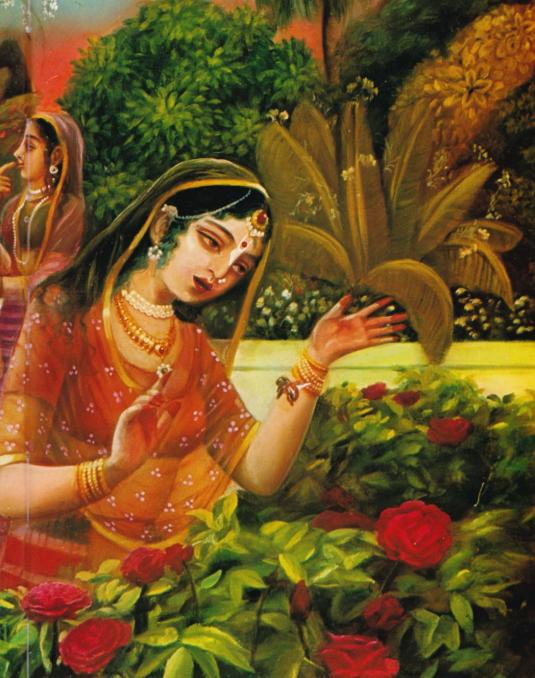Based on the rich colors and detailed clothing, what period or region in India might this painting depict? The painting's vibrant colors, detailed attire, and lush garden setting indicate it might represent a scene from the Mughal era or the Rajput period in India. The elaborate jewelry, intricate textiles, and serene natural backdrop are characteristic of traditional depictions from these periods when art flourished and detailed miniature paintings were common. 